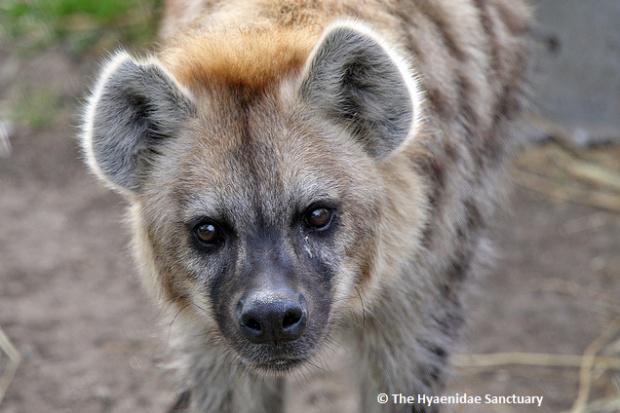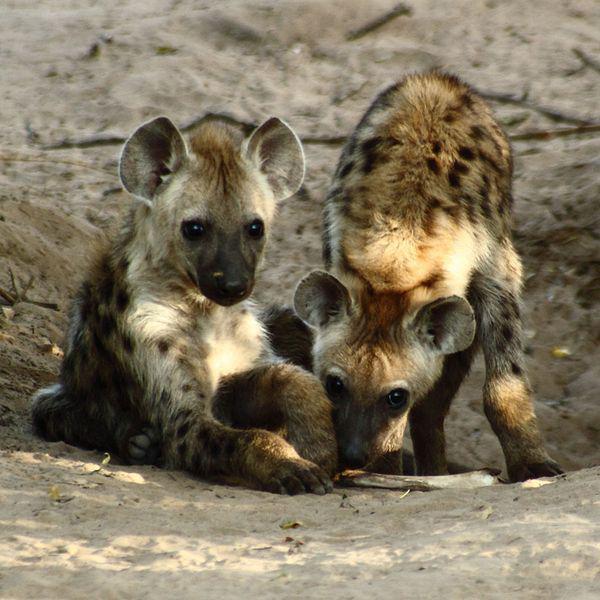The first image is the image on the left, the second image is the image on the right. Assess this claim about the two images: "The left image contains two hyenas.". Correct or not? Answer yes or no. No. The first image is the image on the left, the second image is the image on the right. Analyze the images presented: Is the assertion "An image shows a dark baby hyena posed with its head over the ear of a reclining adult hyena." valid? Answer yes or no. No. 